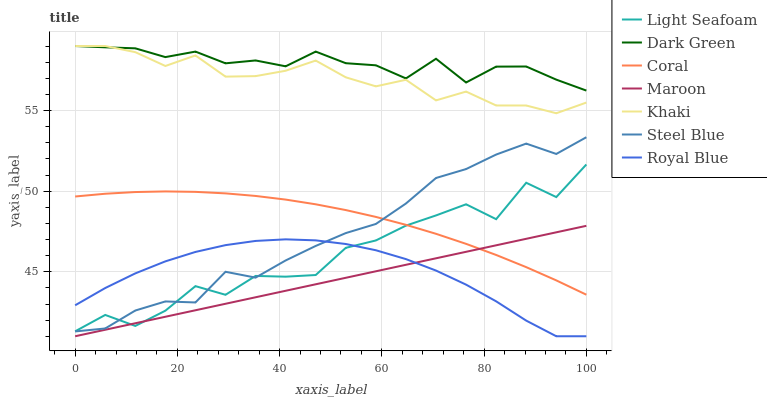Does Maroon have the minimum area under the curve?
Answer yes or no. Yes. Does Dark Green have the maximum area under the curve?
Answer yes or no. Yes. Does Coral have the minimum area under the curve?
Answer yes or no. No. Does Coral have the maximum area under the curve?
Answer yes or no. No. Is Maroon the smoothest?
Answer yes or no. Yes. Is Light Seafoam the roughest?
Answer yes or no. Yes. Is Coral the smoothest?
Answer yes or no. No. Is Coral the roughest?
Answer yes or no. No. Does Maroon have the lowest value?
Answer yes or no. Yes. Does Coral have the lowest value?
Answer yes or no. No. Does Dark Green have the highest value?
Answer yes or no. Yes. Does Coral have the highest value?
Answer yes or no. No. Is Maroon less than Khaki?
Answer yes or no. Yes. Is Khaki greater than Steel Blue?
Answer yes or no. Yes. Does Coral intersect Light Seafoam?
Answer yes or no. Yes. Is Coral less than Light Seafoam?
Answer yes or no. No. Is Coral greater than Light Seafoam?
Answer yes or no. No. Does Maroon intersect Khaki?
Answer yes or no. No. 